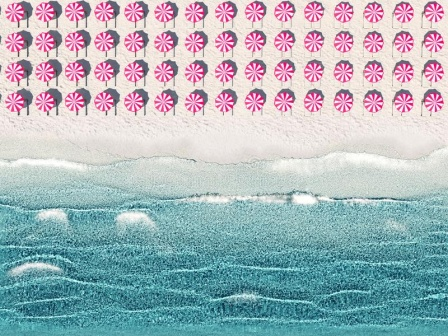Can you provide a more detailed and extended description of the image? Certainly! The image presents a unique and somewhat abstract take on a beach landscape. At the very top, an array of whimsical shapes that resemble peppermint candies in pink and white are arranged in orderly rows, adding a playful and surreal touch to the sky. This artistic choice brings a sense of fantasy to the setting. Below this imaginative sky, we transition to the ocean, represented by undulating blue lines interspersed with white accents that imitate the look of foam. These lines effectively convey the gentle movement of the sea, creating a sense of tranquility. The color palette and wave patterns work together to evoke the rhythmic motion of the ocean. Moving downward, we encounter the sandy beach, depicted with a textured, granular appearance in a soothing beige hue. This portion of the image captures the essence of beach sand, providing a tactile feel through visual representation. The entire scene is framed by a clean, white border that serves to contain and emphasize the serene and imaginative elements within. Overall, the image blends the natural calmness of a beach with whimsical, artistic elements, resulting in a visually striking and thought-provoking piece. What might be the story behind this artistic beach scene? The story behind this artistic beach scene could center around a dreamlike beach from a fantastical world. In this world, the sky isn't just blue - it's an imaginative canvas adorned with whimsical pink and white candy shapes, representing a land where reality blends seamlessly with the surreal. This beach offers the inhabitants a refuge, where the waves gently kiss the shore in rhythmic harmony, depicted through the serene blue and white lines. The sand, meticulously textured and inviting, serves as the foundation where dreams and reality intersect. Perhaps this is a special place where children come to play in a land of their own creation, or where artists find endless inspiration under the enchanting candy-filled sky, melding their reflections of reality with the boundless imagination of their dreams. If you were to give this beach a name, what would it be? I would name this beach 'Peppermint Drift Beach' – a whimsical place where the playful candy sky meets the serene, wavy ocean, inviting dreamers and wanderers alike to bask in its enchanting beauty. 